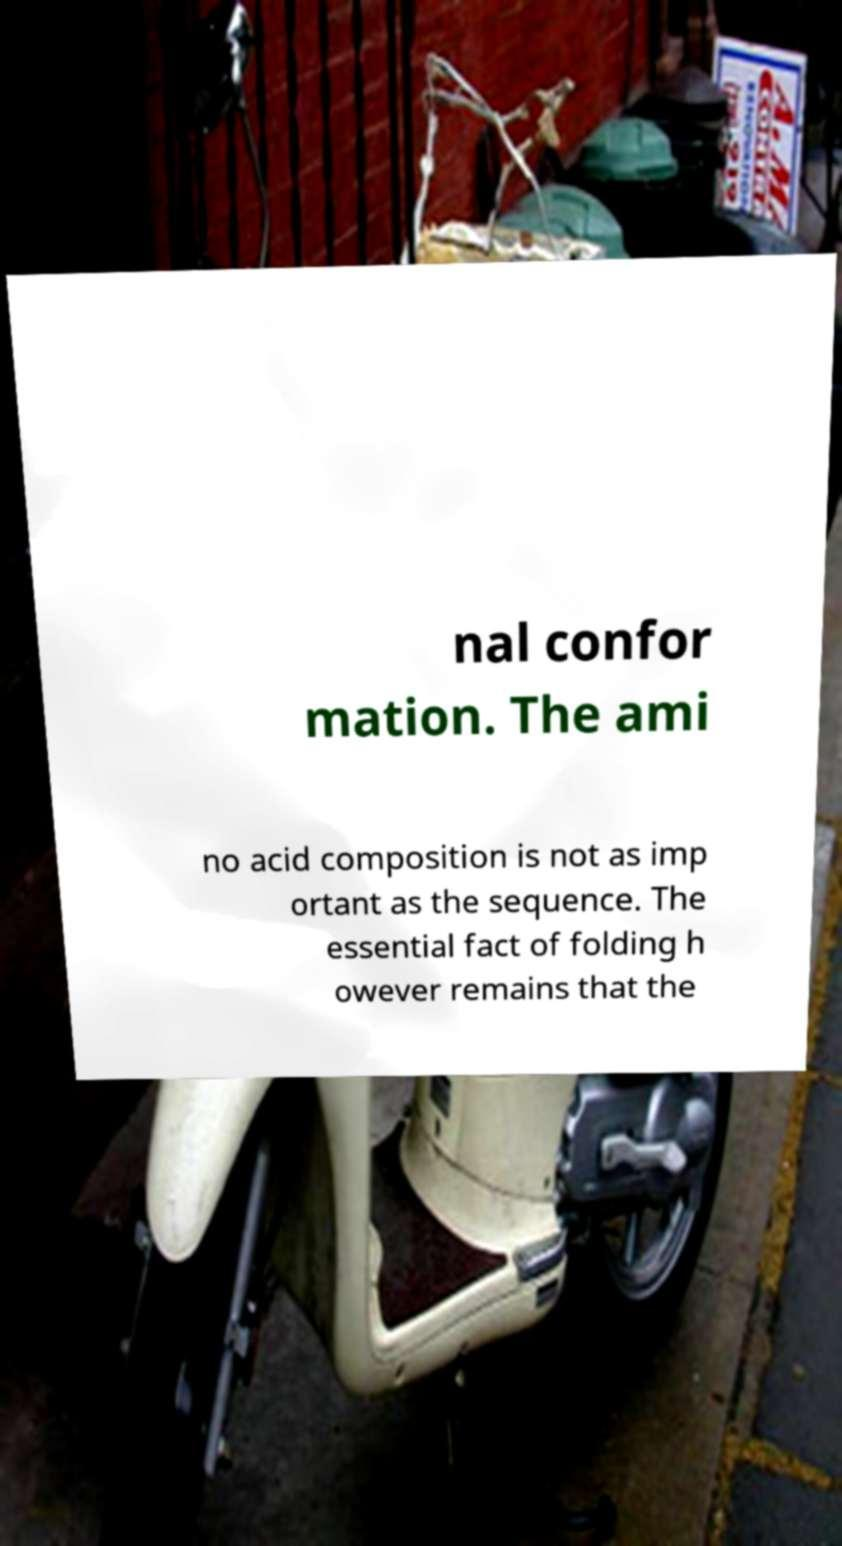Please read and relay the text visible in this image. What does it say? nal confor mation. The ami no acid composition is not as imp ortant as the sequence. The essential fact of folding h owever remains that the 